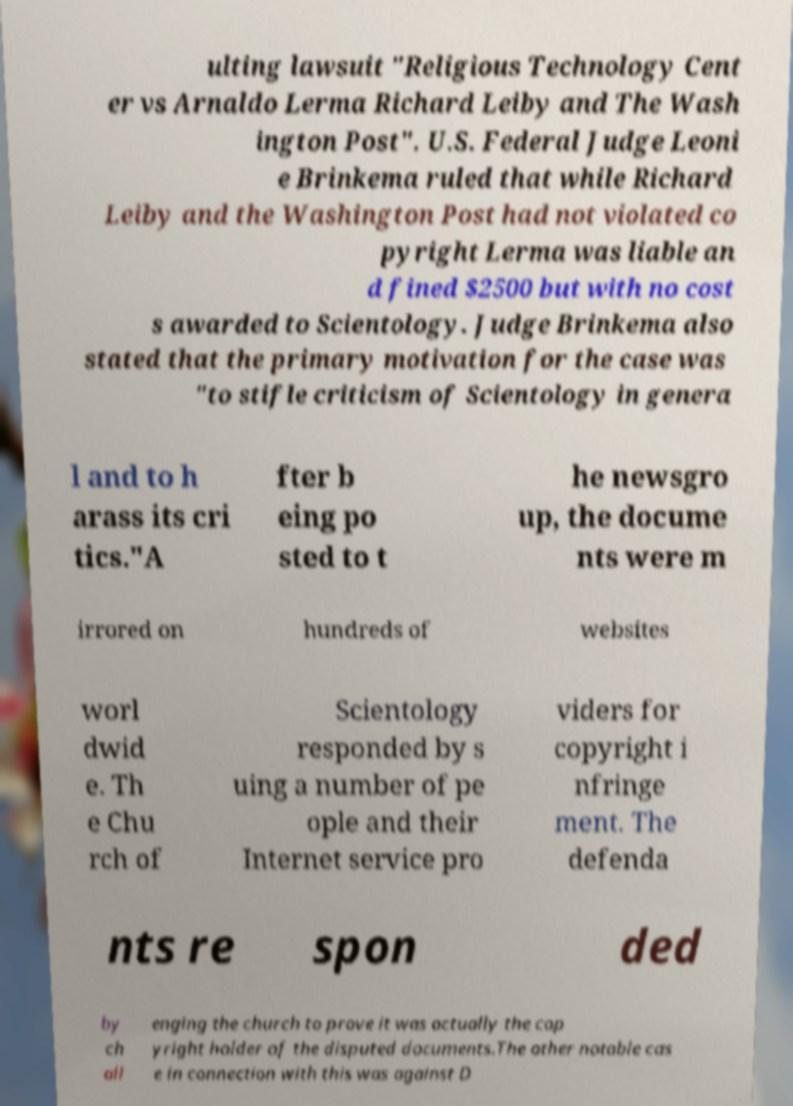For documentation purposes, I need the text within this image transcribed. Could you provide that? ulting lawsuit "Religious Technology Cent er vs Arnaldo Lerma Richard Leiby and The Wash ington Post". U.S. Federal Judge Leoni e Brinkema ruled that while Richard Leiby and the Washington Post had not violated co pyright Lerma was liable an d fined $2500 but with no cost s awarded to Scientology. Judge Brinkema also stated that the primary motivation for the case was "to stifle criticism of Scientology in genera l and to h arass its cri tics."A fter b eing po sted to t he newsgro up, the docume nts were m irrored on hundreds of websites worl dwid e. Th e Chu rch of Scientology responded by s uing a number of pe ople and their Internet service pro viders for copyright i nfringe ment. The defenda nts re spon ded by ch all enging the church to prove it was actually the cop yright holder of the disputed documents.The other notable cas e in connection with this was against D 